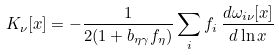<formula> <loc_0><loc_0><loc_500><loc_500>K _ { \nu } [ x ] = - \frac { 1 } { 2 ( 1 + b _ { \eta \gamma } f _ { \eta } ) } \sum _ { i } f _ { i } \, \frac { d \omega _ { i \nu } [ x ] } { d \ln x }</formula> 